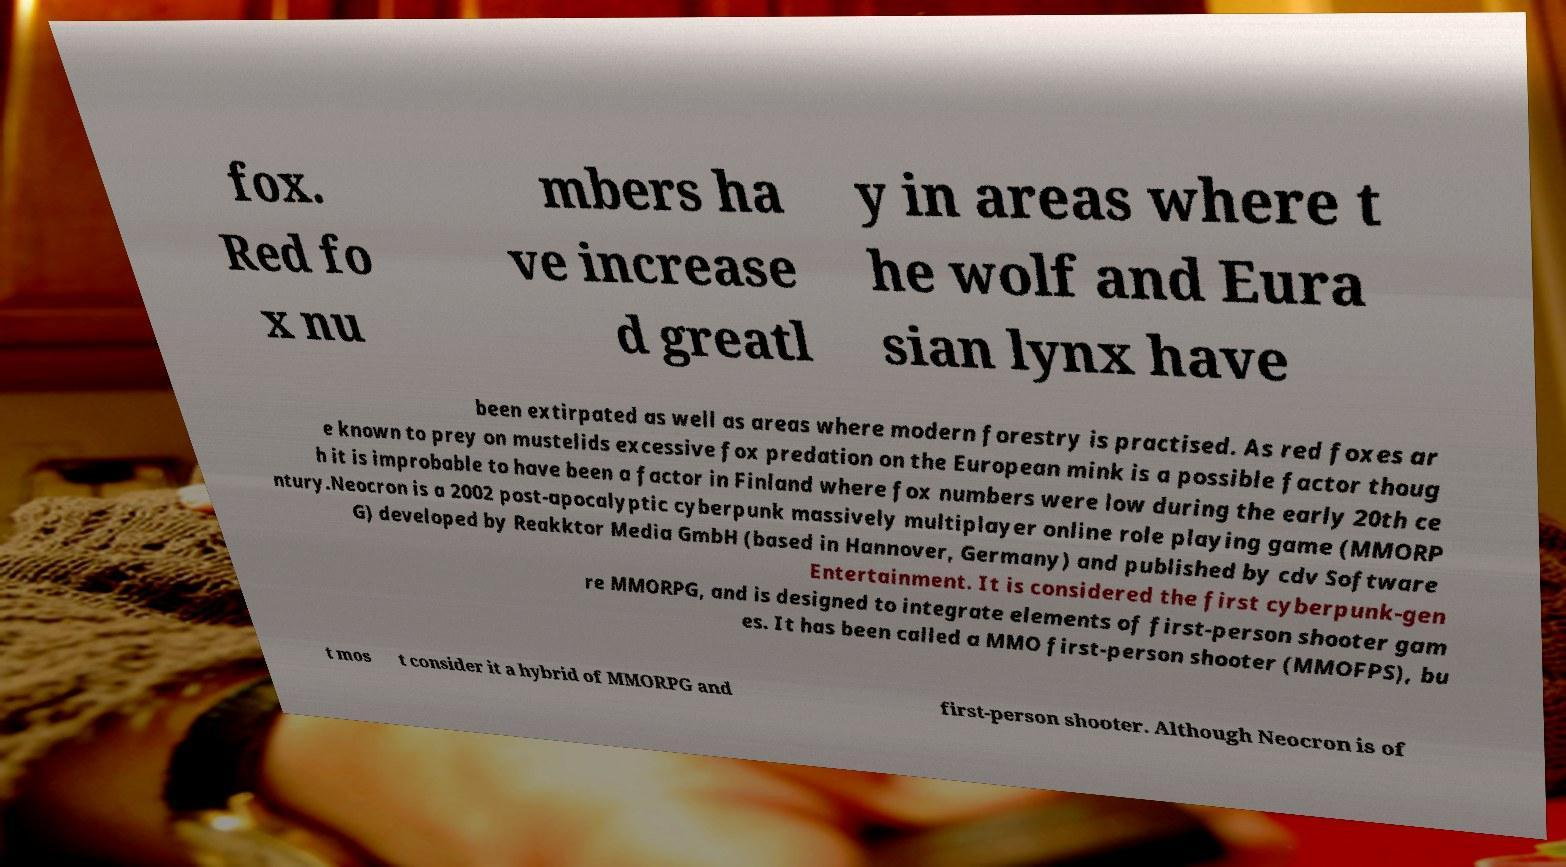Can you accurately transcribe the text from the provided image for me? fox. Red fo x nu mbers ha ve increase d greatl y in areas where t he wolf and Eura sian lynx have been extirpated as well as areas where modern forestry is practised. As red foxes ar e known to prey on mustelids excessive fox predation on the European mink is a possible factor thoug h it is improbable to have been a factor in Finland where fox numbers were low during the early 20th ce ntury.Neocron is a 2002 post-apocalyptic cyberpunk massively multiplayer online role playing game (MMORP G) developed by Reakktor Media GmbH (based in Hannover, Germany) and published by cdv Software Entertainment. It is considered the first cyberpunk-gen re MMORPG, and is designed to integrate elements of first-person shooter gam es. It has been called a MMO first-person shooter (MMOFPS), bu t mos t consider it a hybrid of MMORPG and first-person shooter. Although Neocron is of 